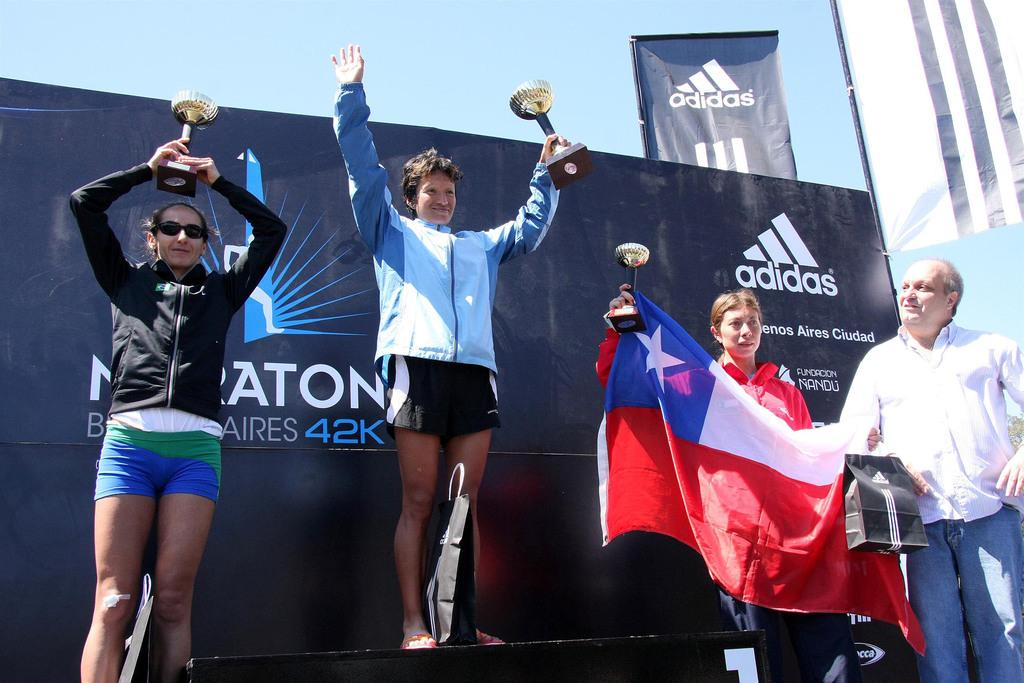<image>
Relay a brief, clear account of the picture shown. Group of people taking a photo in front of a board that says 42k on it. 